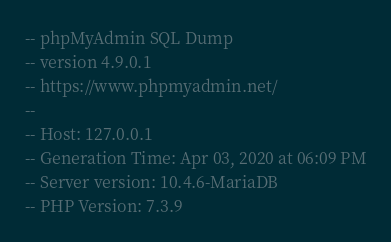<code> <loc_0><loc_0><loc_500><loc_500><_SQL_>-- phpMyAdmin SQL Dump
-- version 4.9.0.1
-- https://www.phpmyadmin.net/
--
-- Host: 127.0.0.1
-- Generation Time: Apr 03, 2020 at 06:09 PM
-- Server version: 10.4.6-MariaDB
-- PHP Version: 7.3.9
</code> 